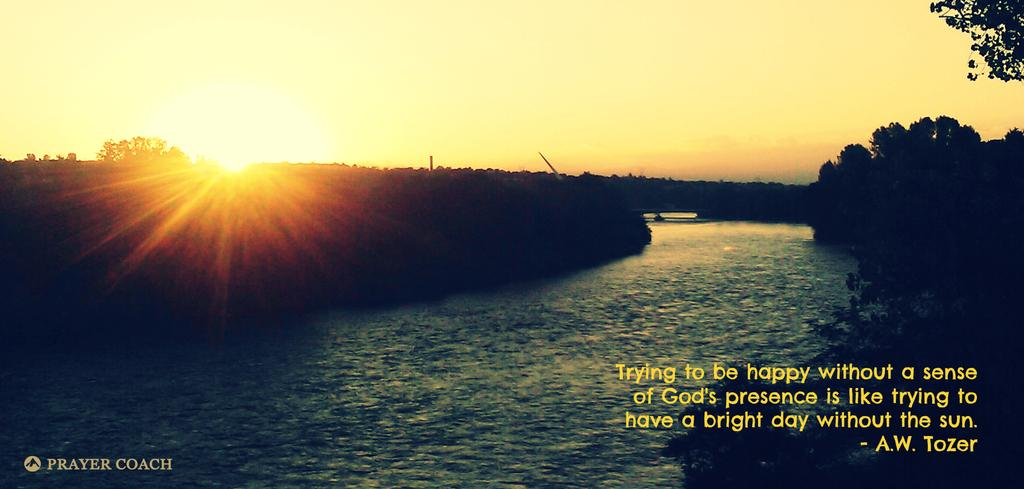What is visible in the image besides the trees? Water, the sky, and the sun are visible in the image. Can you describe the text on the bottom right of the image? There is text on the bottom right of the image, but we cannot determine its content from the image alone. Is there any text on the bottom left of the image? Yes, there is text on the bottom left of the image. How many dimes are visible in the image? There are no dimes present in the image. What fact can be learned from the image about the weather? The image does not provide any specific information about the weather, only that the sky is visible and the sun is observable. 